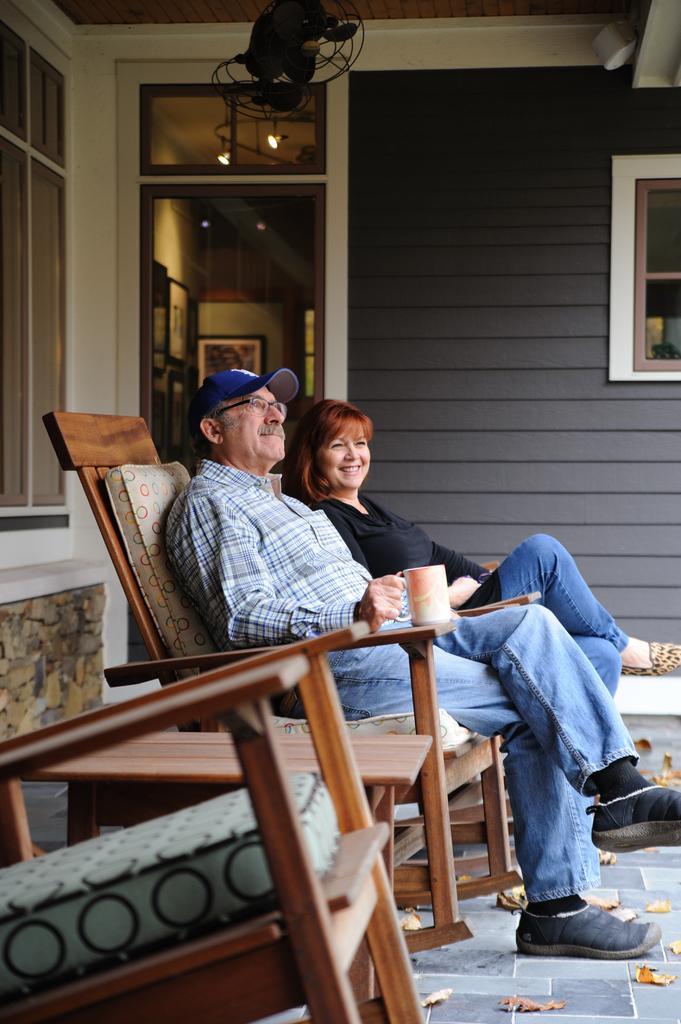Please provide a concise description of this image. There is a man in blue dress is wearing a cap, spectacles is holding a cup and sitting on a chair. Near to him a lady is sitting and smiling. There is a table. In the background there is a wall, door, photo frame, a fan and a window is there. 